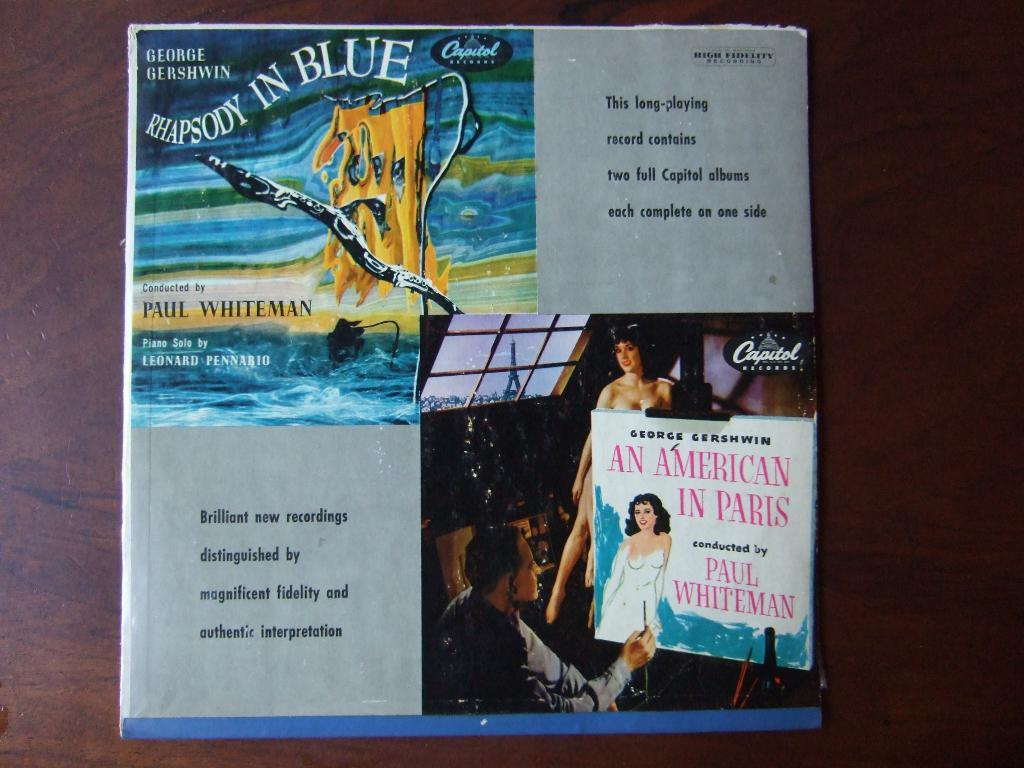<image>
Present a compact description of the photo's key features. Album cover that says "Rhapsody In Blue" on the top and a man painting on the bottom. 